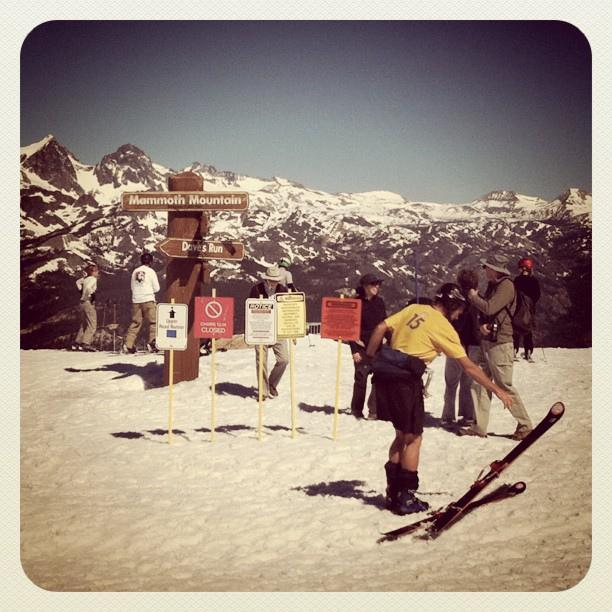Why is the man in the yellow shirt on the mountain? to ski 